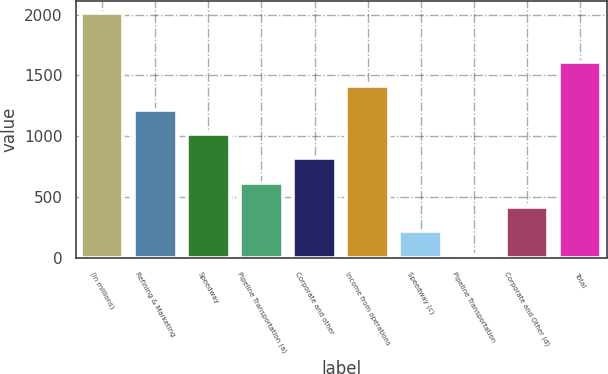<chart> <loc_0><loc_0><loc_500><loc_500><bar_chart><fcel>(In millions)<fcel>Refining & Marketing<fcel>Speedway<fcel>Pipeline Transportation (a)<fcel>Corporate and other<fcel>Income from operations<fcel>Speedway (c)<fcel>Pipeline Transportation<fcel>Corporate and Other (d)<fcel>Total<nl><fcel>2010<fcel>1215.6<fcel>1017<fcel>619.8<fcel>818.4<fcel>1414.2<fcel>222.6<fcel>24<fcel>421.2<fcel>1612.8<nl></chart> 